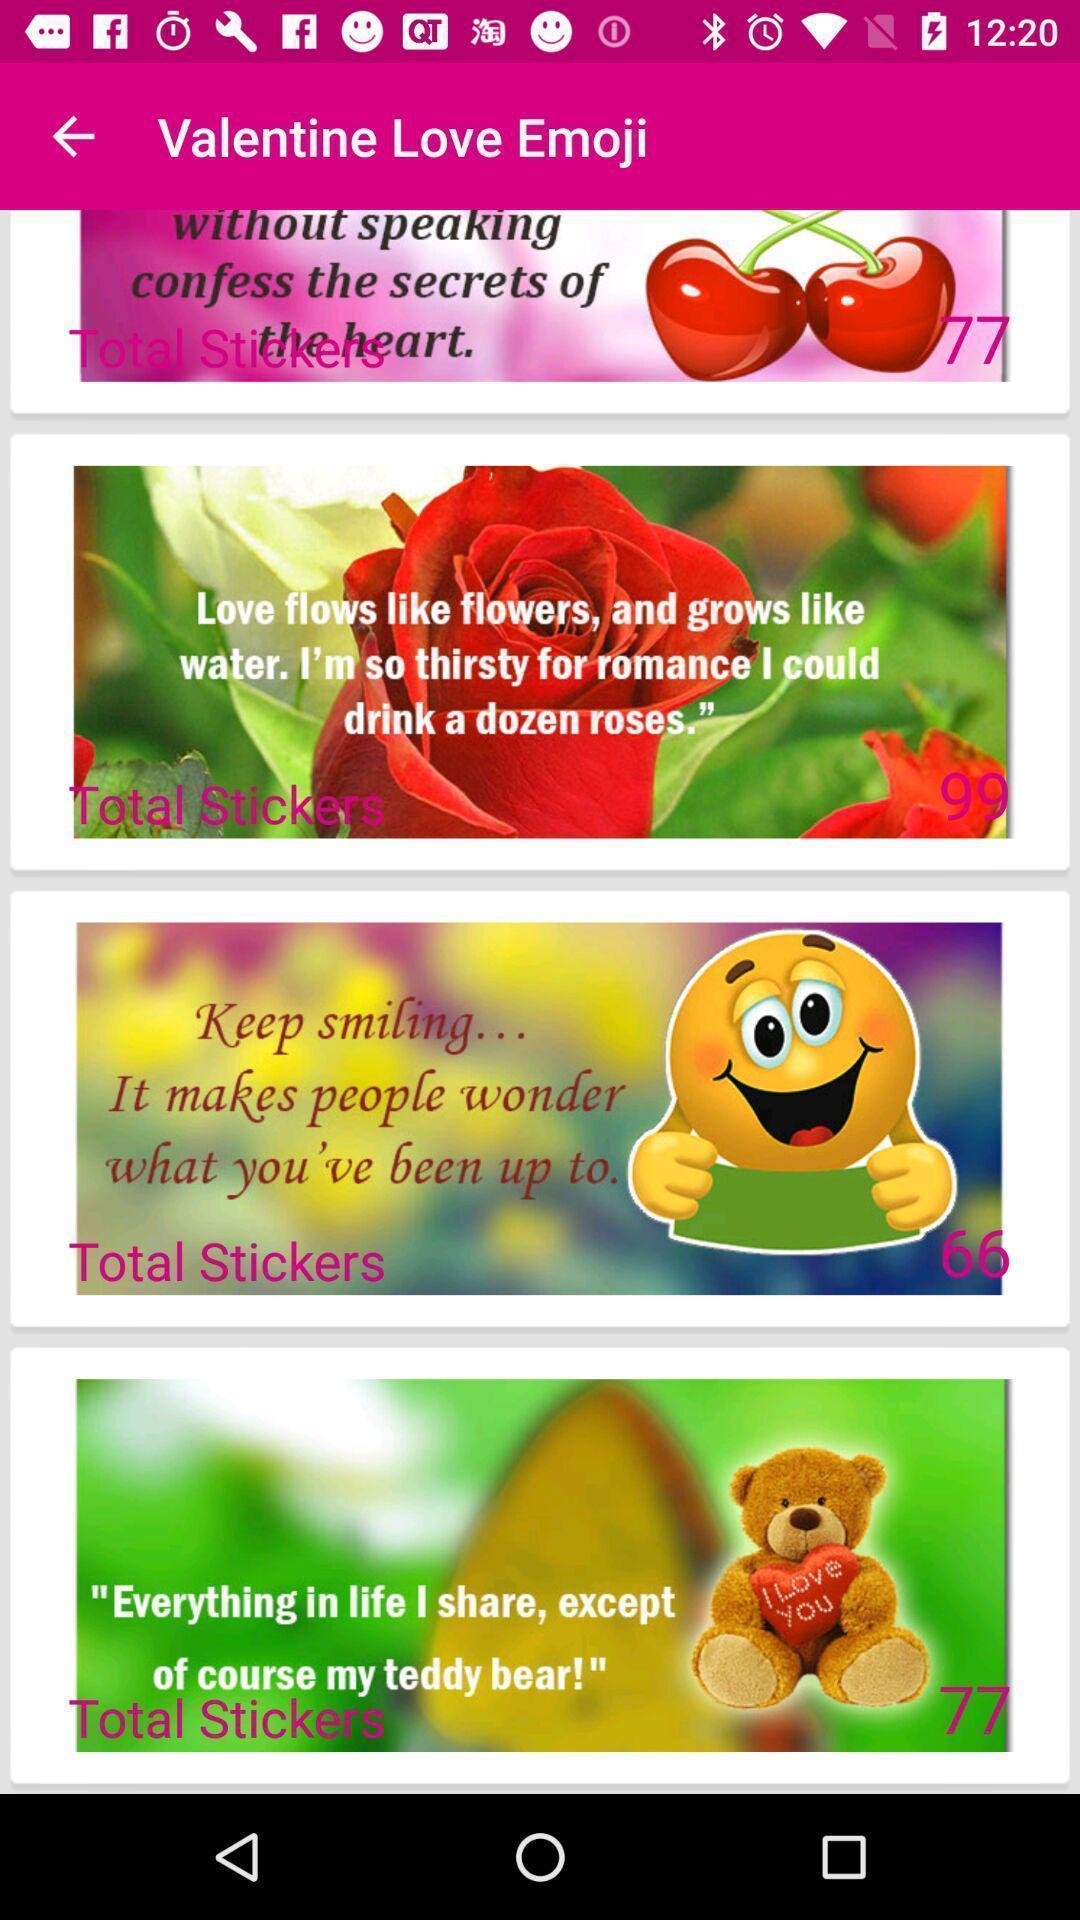Describe the visual elements of this screenshot. Page displaying the list of love emojis. 